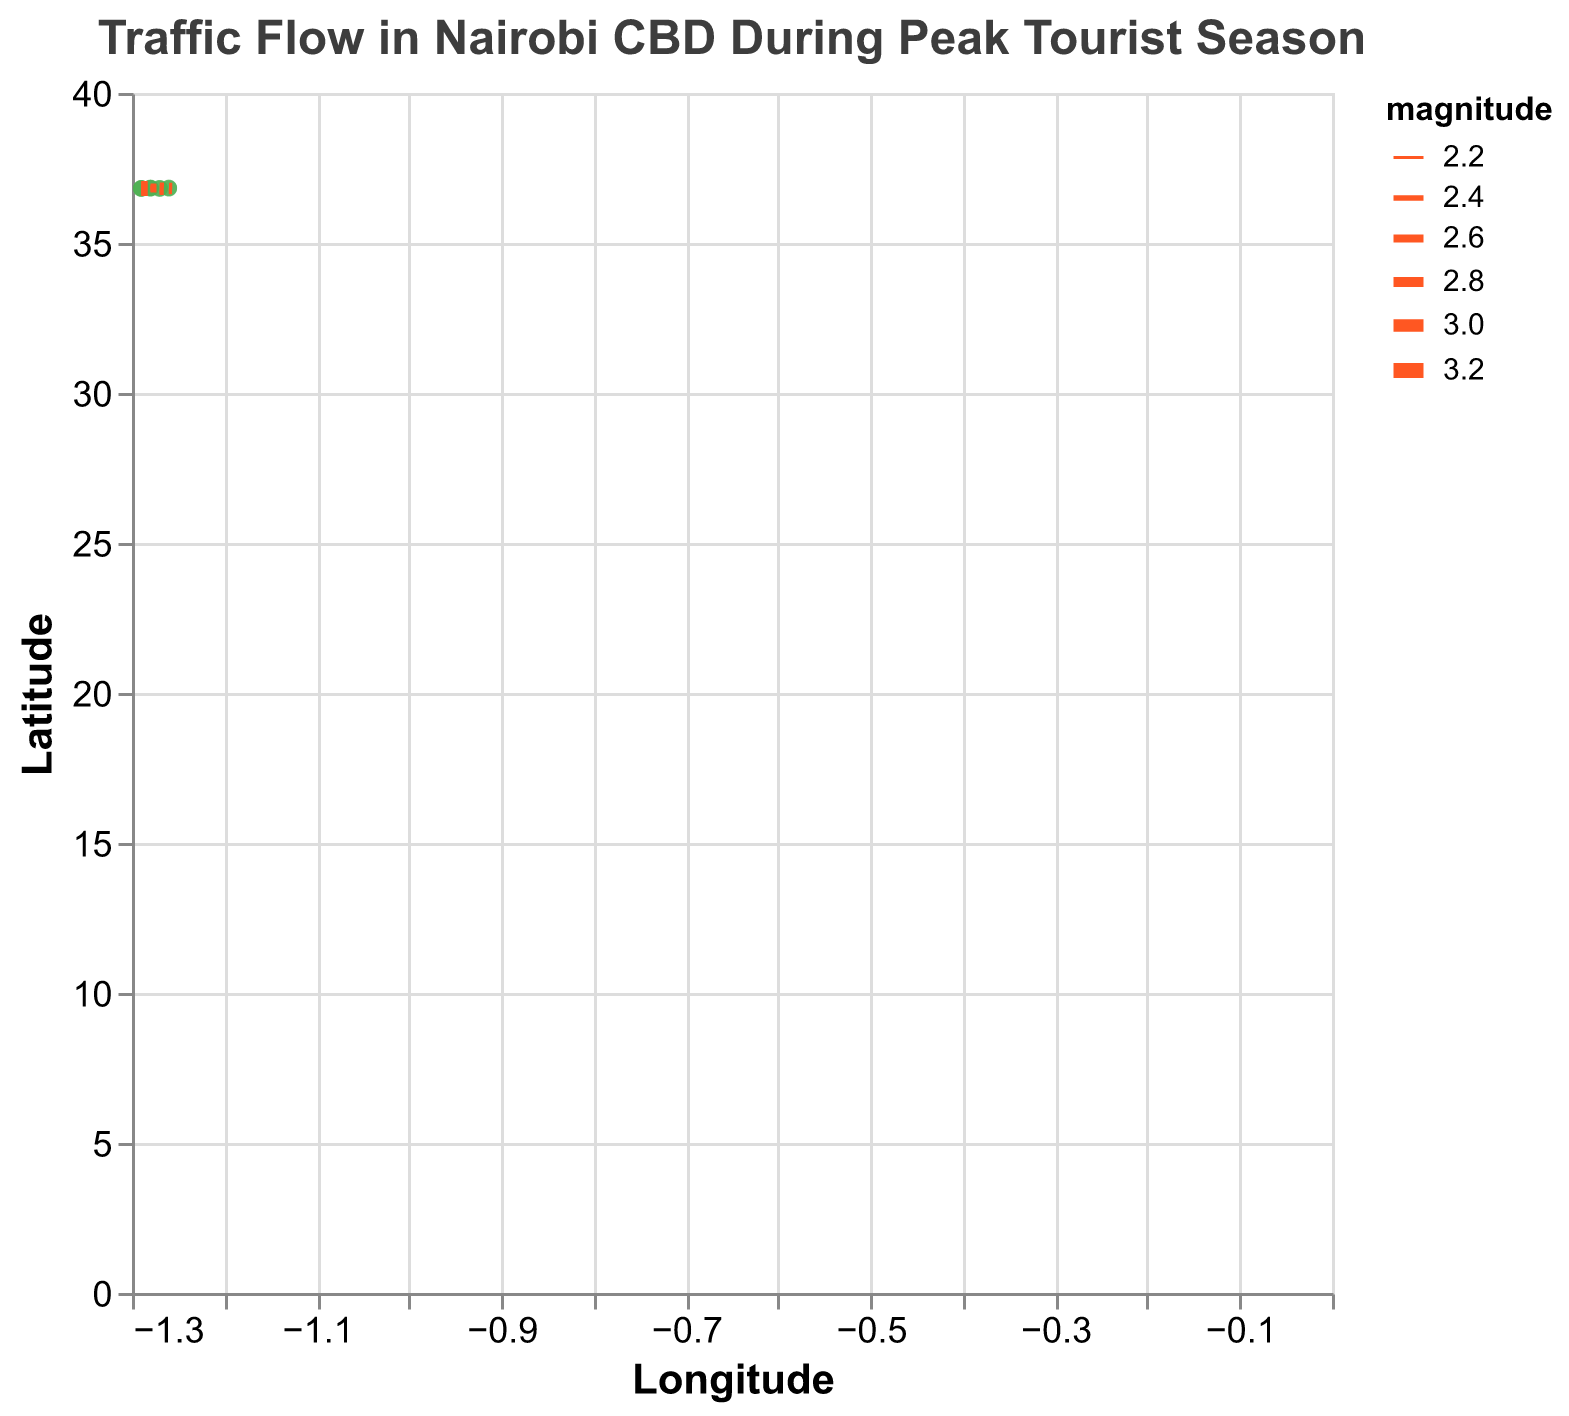What does the title of the plot indicate? The title of the plot is at the top and reads, "Traffic Flow in Nairobi CBD During Peak Tourist Season," indicating that the plot shows the traffic conditions in Nairobi's central business district during the busiest times for tourism.
Answer: Traffic Flow in Nairobi CBD During Peak Tourist Season What are the two variables labeled on the axes? The x-axis is labeled "Longitude," and the y-axis is labeled "Latitude," indicating the geographic coordinates where the data points are located.
Answer: Longitude and Latitude How many data points are represented in the plot? Each arrow on the quiver plot represents a data point. There are 10 pairs of arrows and coordinate points shown.
Answer: 10 Which data point shows the highest traffic magnitude? By observing the width of the arrows, the thickest arrow represents the highest magnitude. The data point at coordinates (-1.29, 36.82) with a magnitude of 3.2 has the thickest arrow.
Answer: (-1.29, 36.82) How is the magnitude of traffic flows visually represented? The magnitude of each traffic flow is represented by the thickness of the arrows; a higher magnitude results in a thicker arrow and vice versa.
Answer: Thickness of arrows What is the general direction of traffic flow within the dataset? By looking at the directions of the arrows, most point generally downward and to the right, indicating traffic flow in south-easterly directions.
Answer: South-eastward Which data points have the smallest traffic magnitudes, and what are their magnitudes? The arrows with the smallest thickness represent the smallest magnitudes. The data points (-1.28, 36.84) and (-1.28, 36.82) have magnitudes of 2.2 and 2.5, respectively.
Answer: (-1.28, 36.84) and (-1.28, 36.82) with 2.2 and 2.5 Compare the scores between (-1.29, 36.82) and (-1.29, 36.81). Which one has a higher magnitude? Looking at the arrow thickness, (-1.29, 36.82) with a magnitude of 3.2 has a higher magnitude compared to (-1.29, 36.81) with 3.1.
Answer: (-1.29, 36.82) What is the traffic direction for the point at (-1.28, 36.84)? The arrow at (-1.28, 36.84) points slightly to the right and downward, indicating the traffic flow toward the southeast.
Answer: Southeast Which data point has the closest coordinate to (-1.27, 36.81) but a different direction of traffic? By checking the coordinates, (-1.29, 36.81) is close to (-1.27, 36.81), and it indicates a less southeast direction due to a smaller downward vector component.
Answer: (-1.29, 36.81) 